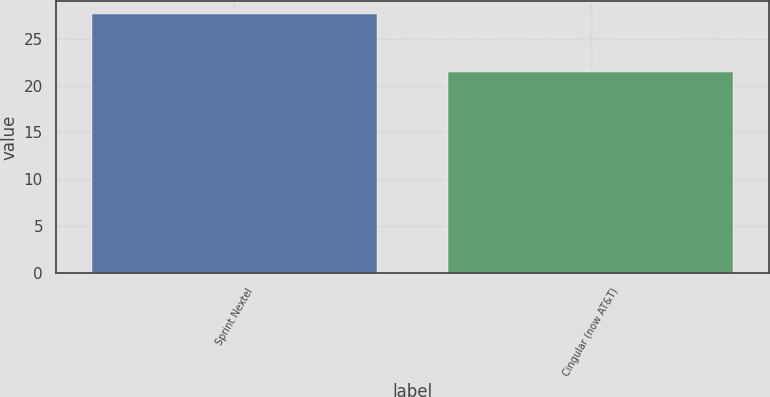Convert chart. <chart><loc_0><loc_0><loc_500><loc_500><bar_chart><fcel>Sprint Nextel<fcel>Cingular (now AT&T)<nl><fcel>27.6<fcel>21.4<nl></chart> 